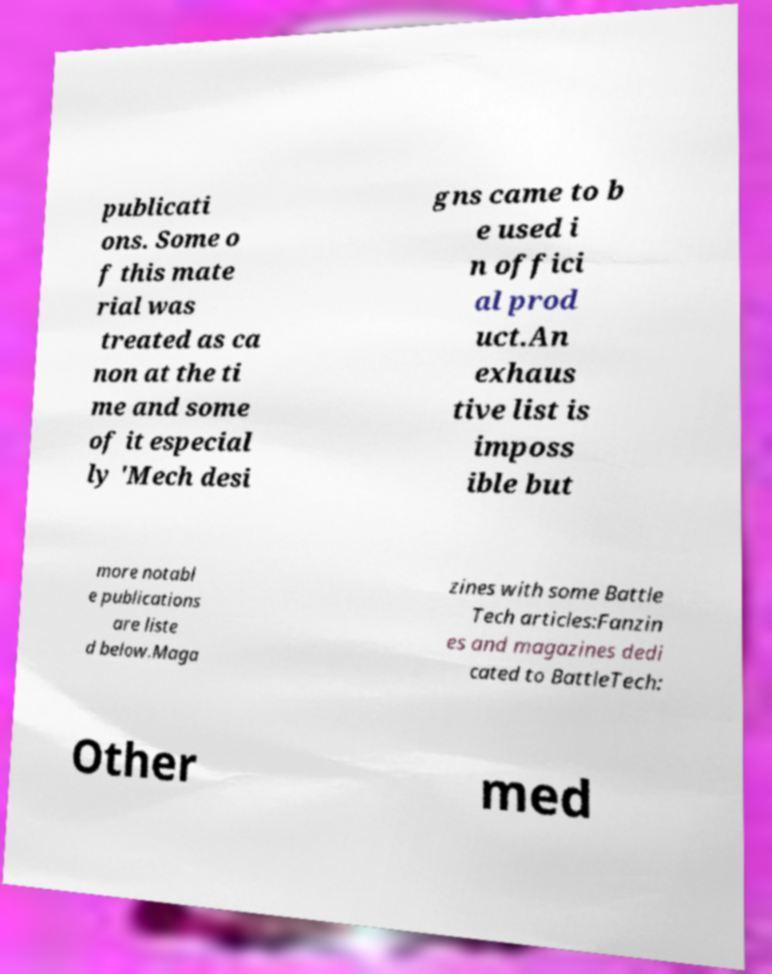Can you accurately transcribe the text from the provided image for me? publicati ons. Some o f this mate rial was treated as ca non at the ti me and some of it especial ly 'Mech desi gns came to b e used i n offici al prod uct.An exhaus tive list is imposs ible but more notabl e publications are liste d below.Maga zines with some Battle Tech articles:Fanzin es and magazines dedi cated to BattleTech: Other med 